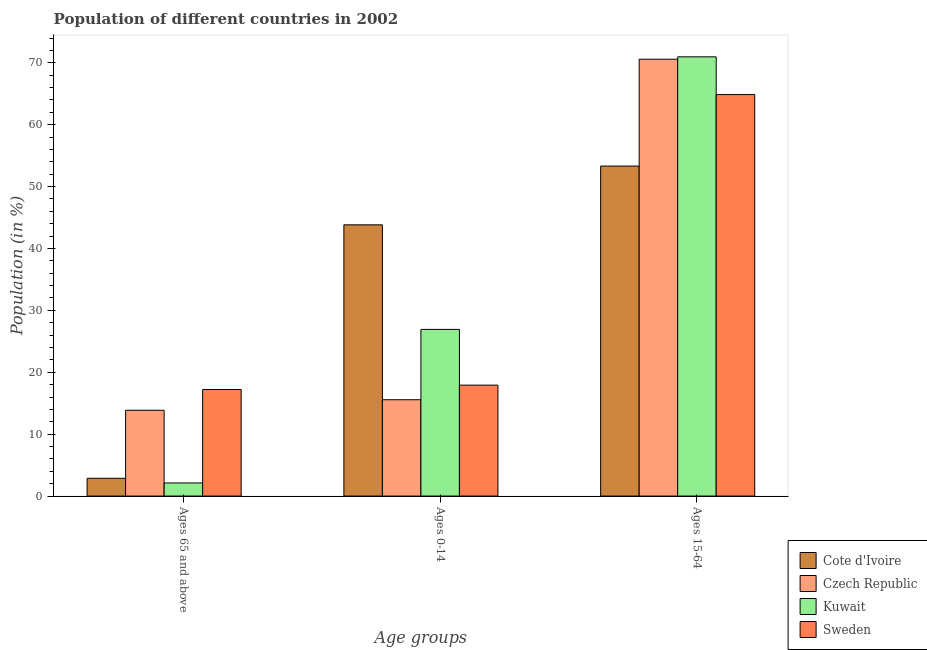How many different coloured bars are there?
Give a very brief answer. 4. How many groups of bars are there?
Make the answer very short. 3. How many bars are there on the 2nd tick from the right?
Give a very brief answer. 4. What is the label of the 2nd group of bars from the left?
Your answer should be compact. Ages 0-14. What is the percentage of population within the age-group of 65 and above in Kuwait?
Provide a short and direct response. 2.12. Across all countries, what is the maximum percentage of population within the age-group 15-64?
Your answer should be very brief. 70.96. Across all countries, what is the minimum percentage of population within the age-group 15-64?
Your answer should be compact. 53.31. In which country was the percentage of population within the age-group 15-64 maximum?
Your answer should be very brief. Kuwait. In which country was the percentage of population within the age-group of 65 and above minimum?
Keep it short and to the point. Kuwait. What is the total percentage of population within the age-group 15-64 in the graph?
Keep it short and to the point. 259.71. What is the difference between the percentage of population within the age-group 15-64 in Czech Republic and that in Kuwait?
Your response must be concise. -0.38. What is the difference between the percentage of population within the age-group 15-64 in Kuwait and the percentage of population within the age-group of 65 and above in Sweden?
Provide a succinct answer. 53.74. What is the average percentage of population within the age-group 0-14 per country?
Ensure brevity in your answer.  26.06. What is the difference between the percentage of population within the age-group 0-14 and percentage of population within the age-group of 65 and above in Kuwait?
Ensure brevity in your answer.  24.81. In how many countries, is the percentage of population within the age-group 15-64 greater than 36 %?
Offer a very short reply. 4. What is the ratio of the percentage of population within the age-group 15-64 in Sweden to that in Cote d'Ivoire?
Offer a very short reply. 1.22. Is the percentage of population within the age-group 0-14 in Kuwait less than that in Sweden?
Offer a terse response. No. What is the difference between the highest and the second highest percentage of population within the age-group 15-64?
Your answer should be compact. 0.38. What is the difference between the highest and the lowest percentage of population within the age-group 15-64?
Keep it short and to the point. 17.64. Is the sum of the percentage of population within the age-group 0-14 in Kuwait and Sweden greater than the maximum percentage of population within the age-group of 65 and above across all countries?
Offer a terse response. Yes. What does the 2nd bar from the left in Ages 65 and above represents?
Offer a very short reply. Czech Republic. Is it the case that in every country, the sum of the percentage of population within the age-group of 65 and above and percentage of population within the age-group 0-14 is greater than the percentage of population within the age-group 15-64?
Your answer should be compact. No. How many bars are there?
Offer a very short reply. 12. How many countries are there in the graph?
Your answer should be compact. 4. Does the graph contain any zero values?
Give a very brief answer. No. Where does the legend appear in the graph?
Keep it short and to the point. Bottom right. What is the title of the graph?
Keep it short and to the point. Population of different countries in 2002. Does "Curacao" appear as one of the legend labels in the graph?
Make the answer very short. No. What is the label or title of the X-axis?
Provide a succinct answer. Age groups. What is the label or title of the Y-axis?
Provide a succinct answer. Population (in %). What is the Population (in %) in Cote d'Ivoire in Ages 65 and above?
Give a very brief answer. 2.87. What is the Population (in %) in Czech Republic in Ages 65 and above?
Your answer should be compact. 13.86. What is the Population (in %) of Kuwait in Ages 65 and above?
Provide a short and direct response. 2.12. What is the Population (in %) of Sweden in Ages 65 and above?
Your answer should be compact. 17.22. What is the Population (in %) of Cote d'Ivoire in Ages 0-14?
Your answer should be very brief. 43.82. What is the Population (in %) in Czech Republic in Ages 0-14?
Your answer should be very brief. 15.56. What is the Population (in %) in Kuwait in Ages 0-14?
Offer a very short reply. 26.93. What is the Population (in %) in Sweden in Ages 0-14?
Your answer should be compact. 17.92. What is the Population (in %) of Cote d'Ivoire in Ages 15-64?
Keep it short and to the point. 53.31. What is the Population (in %) in Czech Republic in Ages 15-64?
Offer a terse response. 70.57. What is the Population (in %) of Kuwait in Ages 15-64?
Keep it short and to the point. 70.96. What is the Population (in %) of Sweden in Ages 15-64?
Ensure brevity in your answer.  64.86. Across all Age groups, what is the maximum Population (in %) of Cote d'Ivoire?
Make the answer very short. 53.31. Across all Age groups, what is the maximum Population (in %) of Czech Republic?
Give a very brief answer. 70.57. Across all Age groups, what is the maximum Population (in %) in Kuwait?
Your answer should be compact. 70.96. Across all Age groups, what is the maximum Population (in %) in Sweden?
Make the answer very short. 64.86. Across all Age groups, what is the minimum Population (in %) in Cote d'Ivoire?
Your response must be concise. 2.87. Across all Age groups, what is the minimum Population (in %) of Czech Republic?
Offer a very short reply. 13.86. Across all Age groups, what is the minimum Population (in %) of Kuwait?
Your response must be concise. 2.12. Across all Age groups, what is the minimum Population (in %) in Sweden?
Ensure brevity in your answer.  17.22. What is the difference between the Population (in %) of Cote d'Ivoire in Ages 65 and above and that in Ages 0-14?
Make the answer very short. -40.95. What is the difference between the Population (in %) in Czech Republic in Ages 65 and above and that in Ages 0-14?
Keep it short and to the point. -1.7. What is the difference between the Population (in %) of Kuwait in Ages 65 and above and that in Ages 0-14?
Give a very brief answer. -24.81. What is the difference between the Population (in %) of Sweden in Ages 65 and above and that in Ages 0-14?
Give a very brief answer. -0.7. What is the difference between the Population (in %) in Cote d'Ivoire in Ages 65 and above and that in Ages 15-64?
Ensure brevity in your answer.  -50.45. What is the difference between the Population (in %) of Czech Republic in Ages 65 and above and that in Ages 15-64?
Your answer should be very brief. -56.71. What is the difference between the Population (in %) in Kuwait in Ages 65 and above and that in Ages 15-64?
Your answer should be very brief. -68.84. What is the difference between the Population (in %) in Sweden in Ages 65 and above and that in Ages 15-64?
Your response must be concise. -47.64. What is the difference between the Population (in %) of Cote d'Ivoire in Ages 0-14 and that in Ages 15-64?
Your response must be concise. -9.5. What is the difference between the Population (in %) of Czech Republic in Ages 0-14 and that in Ages 15-64?
Provide a succinct answer. -55.01. What is the difference between the Population (in %) in Kuwait in Ages 0-14 and that in Ages 15-64?
Your response must be concise. -44.03. What is the difference between the Population (in %) in Sweden in Ages 0-14 and that in Ages 15-64?
Make the answer very short. -46.94. What is the difference between the Population (in %) in Cote d'Ivoire in Ages 65 and above and the Population (in %) in Czech Republic in Ages 0-14?
Your answer should be compact. -12.7. What is the difference between the Population (in %) in Cote d'Ivoire in Ages 65 and above and the Population (in %) in Kuwait in Ages 0-14?
Provide a succinct answer. -24.06. What is the difference between the Population (in %) in Cote d'Ivoire in Ages 65 and above and the Population (in %) in Sweden in Ages 0-14?
Offer a very short reply. -15.05. What is the difference between the Population (in %) of Czech Republic in Ages 65 and above and the Population (in %) of Kuwait in Ages 0-14?
Make the answer very short. -13.07. What is the difference between the Population (in %) in Czech Republic in Ages 65 and above and the Population (in %) in Sweden in Ages 0-14?
Keep it short and to the point. -4.06. What is the difference between the Population (in %) in Kuwait in Ages 65 and above and the Population (in %) in Sweden in Ages 0-14?
Give a very brief answer. -15.8. What is the difference between the Population (in %) in Cote d'Ivoire in Ages 65 and above and the Population (in %) in Czech Republic in Ages 15-64?
Your answer should be very brief. -67.71. What is the difference between the Population (in %) in Cote d'Ivoire in Ages 65 and above and the Population (in %) in Kuwait in Ages 15-64?
Make the answer very short. -68.09. What is the difference between the Population (in %) of Cote d'Ivoire in Ages 65 and above and the Population (in %) of Sweden in Ages 15-64?
Offer a very short reply. -61.99. What is the difference between the Population (in %) of Czech Republic in Ages 65 and above and the Population (in %) of Kuwait in Ages 15-64?
Give a very brief answer. -57.1. What is the difference between the Population (in %) in Czech Republic in Ages 65 and above and the Population (in %) in Sweden in Ages 15-64?
Offer a terse response. -51. What is the difference between the Population (in %) of Kuwait in Ages 65 and above and the Population (in %) of Sweden in Ages 15-64?
Give a very brief answer. -62.75. What is the difference between the Population (in %) of Cote d'Ivoire in Ages 0-14 and the Population (in %) of Czech Republic in Ages 15-64?
Your answer should be compact. -26.76. What is the difference between the Population (in %) in Cote d'Ivoire in Ages 0-14 and the Population (in %) in Kuwait in Ages 15-64?
Offer a terse response. -27.14. What is the difference between the Population (in %) of Cote d'Ivoire in Ages 0-14 and the Population (in %) of Sweden in Ages 15-64?
Your answer should be very brief. -21.04. What is the difference between the Population (in %) in Czech Republic in Ages 0-14 and the Population (in %) in Kuwait in Ages 15-64?
Your answer should be very brief. -55.39. What is the difference between the Population (in %) in Czech Republic in Ages 0-14 and the Population (in %) in Sweden in Ages 15-64?
Ensure brevity in your answer.  -49.3. What is the difference between the Population (in %) in Kuwait in Ages 0-14 and the Population (in %) in Sweden in Ages 15-64?
Ensure brevity in your answer.  -37.94. What is the average Population (in %) in Cote d'Ivoire per Age groups?
Give a very brief answer. 33.33. What is the average Population (in %) in Czech Republic per Age groups?
Your answer should be compact. 33.33. What is the average Population (in %) of Kuwait per Age groups?
Provide a short and direct response. 33.33. What is the average Population (in %) in Sweden per Age groups?
Keep it short and to the point. 33.33. What is the difference between the Population (in %) in Cote d'Ivoire and Population (in %) in Czech Republic in Ages 65 and above?
Ensure brevity in your answer.  -10.99. What is the difference between the Population (in %) in Cote d'Ivoire and Population (in %) in Kuwait in Ages 65 and above?
Your response must be concise. 0.75. What is the difference between the Population (in %) of Cote d'Ivoire and Population (in %) of Sweden in Ages 65 and above?
Give a very brief answer. -14.35. What is the difference between the Population (in %) in Czech Republic and Population (in %) in Kuwait in Ages 65 and above?
Your answer should be very brief. 11.74. What is the difference between the Population (in %) in Czech Republic and Population (in %) in Sweden in Ages 65 and above?
Provide a succinct answer. -3.36. What is the difference between the Population (in %) in Kuwait and Population (in %) in Sweden in Ages 65 and above?
Offer a very short reply. -15.1. What is the difference between the Population (in %) of Cote d'Ivoire and Population (in %) of Czech Republic in Ages 0-14?
Make the answer very short. 28.25. What is the difference between the Population (in %) of Cote d'Ivoire and Population (in %) of Kuwait in Ages 0-14?
Provide a short and direct response. 16.89. What is the difference between the Population (in %) of Cote d'Ivoire and Population (in %) of Sweden in Ages 0-14?
Provide a short and direct response. 25.9. What is the difference between the Population (in %) of Czech Republic and Population (in %) of Kuwait in Ages 0-14?
Your answer should be compact. -11.36. What is the difference between the Population (in %) of Czech Republic and Population (in %) of Sweden in Ages 0-14?
Provide a succinct answer. -2.36. What is the difference between the Population (in %) in Kuwait and Population (in %) in Sweden in Ages 0-14?
Your response must be concise. 9.01. What is the difference between the Population (in %) in Cote d'Ivoire and Population (in %) in Czech Republic in Ages 15-64?
Give a very brief answer. -17.26. What is the difference between the Population (in %) in Cote d'Ivoire and Population (in %) in Kuwait in Ages 15-64?
Provide a short and direct response. -17.64. What is the difference between the Population (in %) in Cote d'Ivoire and Population (in %) in Sweden in Ages 15-64?
Ensure brevity in your answer.  -11.55. What is the difference between the Population (in %) of Czech Republic and Population (in %) of Kuwait in Ages 15-64?
Make the answer very short. -0.38. What is the difference between the Population (in %) of Czech Republic and Population (in %) of Sweden in Ages 15-64?
Ensure brevity in your answer.  5.71. What is the difference between the Population (in %) in Kuwait and Population (in %) in Sweden in Ages 15-64?
Offer a very short reply. 6.1. What is the ratio of the Population (in %) of Cote d'Ivoire in Ages 65 and above to that in Ages 0-14?
Ensure brevity in your answer.  0.07. What is the ratio of the Population (in %) of Czech Republic in Ages 65 and above to that in Ages 0-14?
Your answer should be compact. 0.89. What is the ratio of the Population (in %) of Kuwait in Ages 65 and above to that in Ages 0-14?
Your response must be concise. 0.08. What is the ratio of the Population (in %) of Sweden in Ages 65 and above to that in Ages 0-14?
Your answer should be compact. 0.96. What is the ratio of the Population (in %) in Cote d'Ivoire in Ages 65 and above to that in Ages 15-64?
Keep it short and to the point. 0.05. What is the ratio of the Population (in %) in Czech Republic in Ages 65 and above to that in Ages 15-64?
Offer a terse response. 0.2. What is the ratio of the Population (in %) in Kuwait in Ages 65 and above to that in Ages 15-64?
Offer a terse response. 0.03. What is the ratio of the Population (in %) of Sweden in Ages 65 and above to that in Ages 15-64?
Make the answer very short. 0.27. What is the ratio of the Population (in %) in Cote d'Ivoire in Ages 0-14 to that in Ages 15-64?
Keep it short and to the point. 0.82. What is the ratio of the Population (in %) of Czech Republic in Ages 0-14 to that in Ages 15-64?
Your response must be concise. 0.22. What is the ratio of the Population (in %) of Kuwait in Ages 0-14 to that in Ages 15-64?
Your answer should be very brief. 0.38. What is the ratio of the Population (in %) of Sweden in Ages 0-14 to that in Ages 15-64?
Provide a short and direct response. 0.28. What is the difference between the highest and the second highest Population (in %) of Cote d'Ivoire?
Keep it short and to the point. 9.5. What is the difference between the highest and the second highest Population (in %) in Czech Republic?
Your response must be concise. 55.01. What is the difference between the highest and the second highest Population (in %) of Kuwait?
Ensure brevity in your answer.  44.03. What is the difference between the highest and the second highest Population (in %) of Sweden?
Ensure brevity in your answer.  46.94. What is the difference between the highest and the lowest Population (in %) of Cote d'Ivoire?
Your response must be concise. 50.45. What is the difference between the highest and the lowest Population (in %) of Czech Republic?
Offer a terse response. 56.71. What is the difference between the highest and the lowest Population (in %) in Kuwait?
Your answer should be very brief. 68.84. What is the difference between the highest and the lowest Population (in %) of Sweden?
Keep it short and to the point. 47.64. 